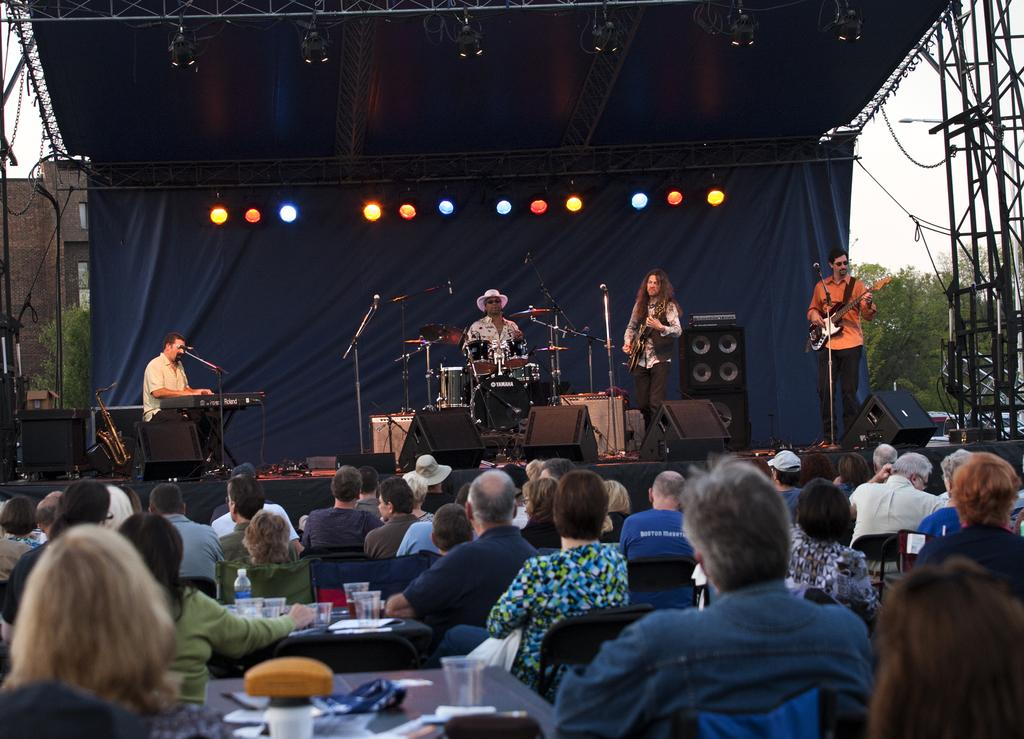What is happening on the stage in the image? There is a rock band performing on a stage. What are the people in the image doing? There are people sitting and watching the performance. How many screws can be seen holding the stage together in the image? There is no mention of screws in the image, and therefore it is not possible to determine the number of screws present. What is the name of the downtown area where the performance is taking place? The image does not provide any information about the location of the performance, so it is not possible to determine if it is in a downtown area or not. 